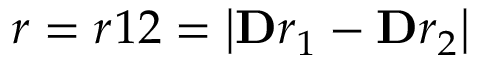<formula> <loc_0><loc_0><loc_500><loc_500>r = r 1 2 = \left | \mathbf r _ { 1 } - \mathbf r _ { 2 } \right |</formula> 